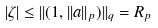Convert formula to latex. <formula><loc_0><loc_0><loc_500><loc_500>| \zeta | \leq | | ( 1 , | | a | | _ { p } ) | | _ { q } = R _ { p }</formula> 